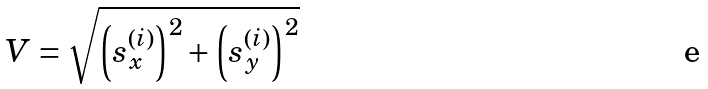<formula> <loc_0><loc_0><loc_500><loc_500>V = \sqrt { \left ( s _ { x } ^ { \left ( i \right ) } \right ) ^ { 2 } + \left ( s _ { y } ^ { \left ( i \right ) } \right ) ^ { 2 } }</formula> 